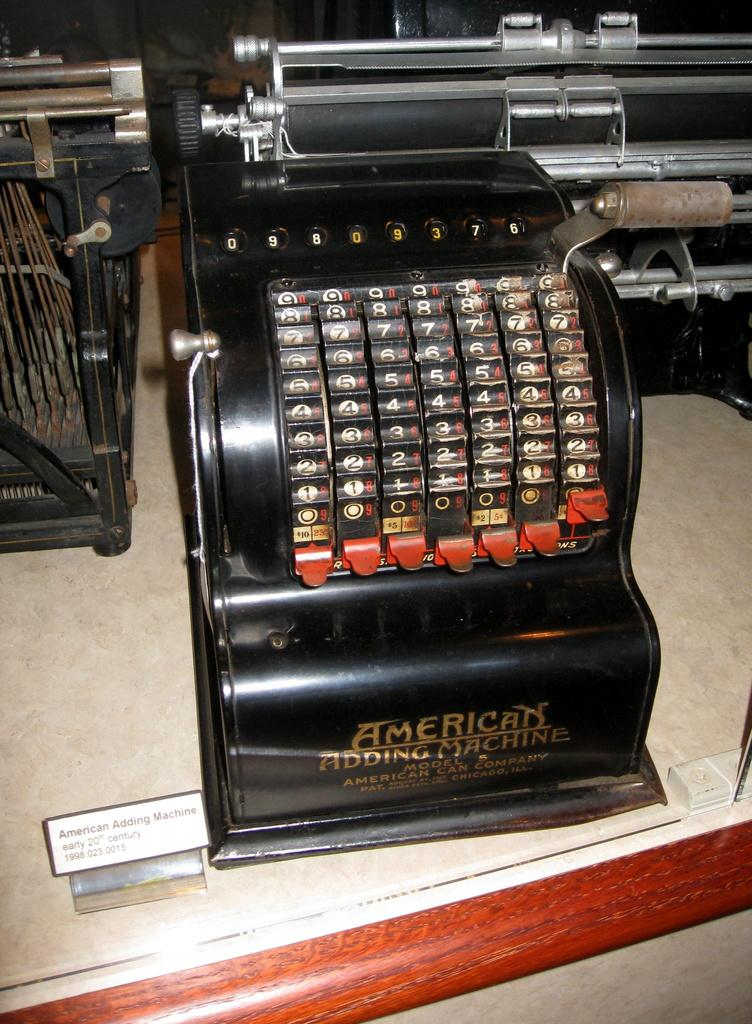Provide a one-sentence caption for the provided image. An adding machine by the American Can Company dates from the early 1900s. 